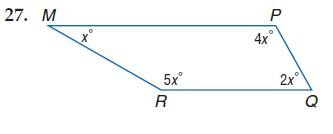Answer the mathemtical geometry problem and directly provide the correct option letter.
Question: Find m \angle Q.
Choices: A: 30 B: 60 C: 120 D: 150 B 